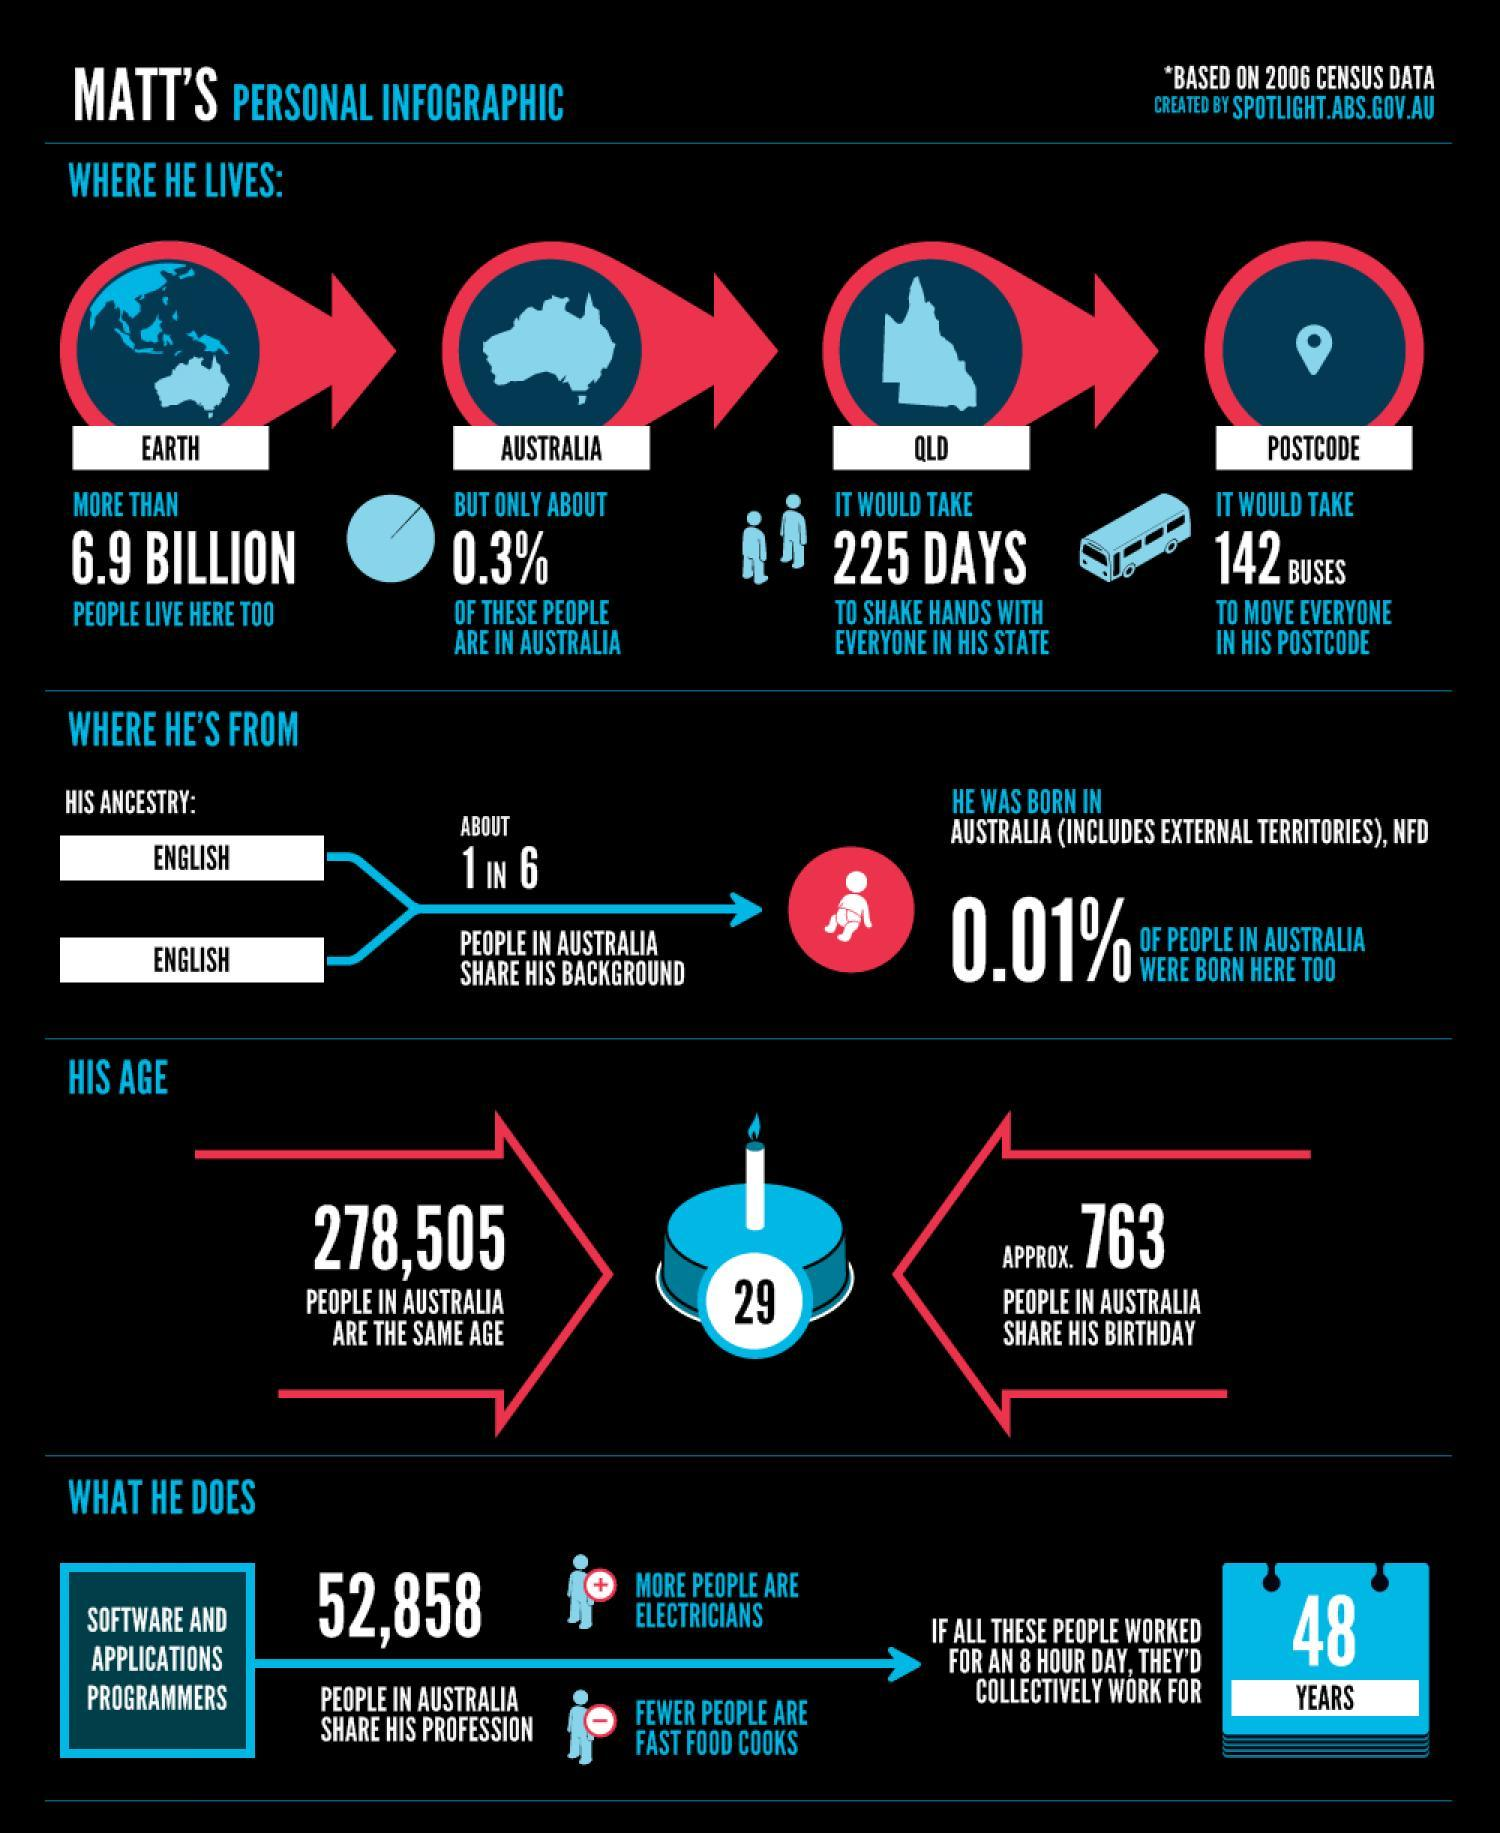How old is Matt?
Answer the question with a short phrase. 29 What percentage of people in the world live outside Australia? 99.7 How long it takes for Matt to shake hands with everyone in his state? 225 days How many people in Australia are of same age as Matt? 278,505 How many People born on same day where Matt was born? APPROX. 763 